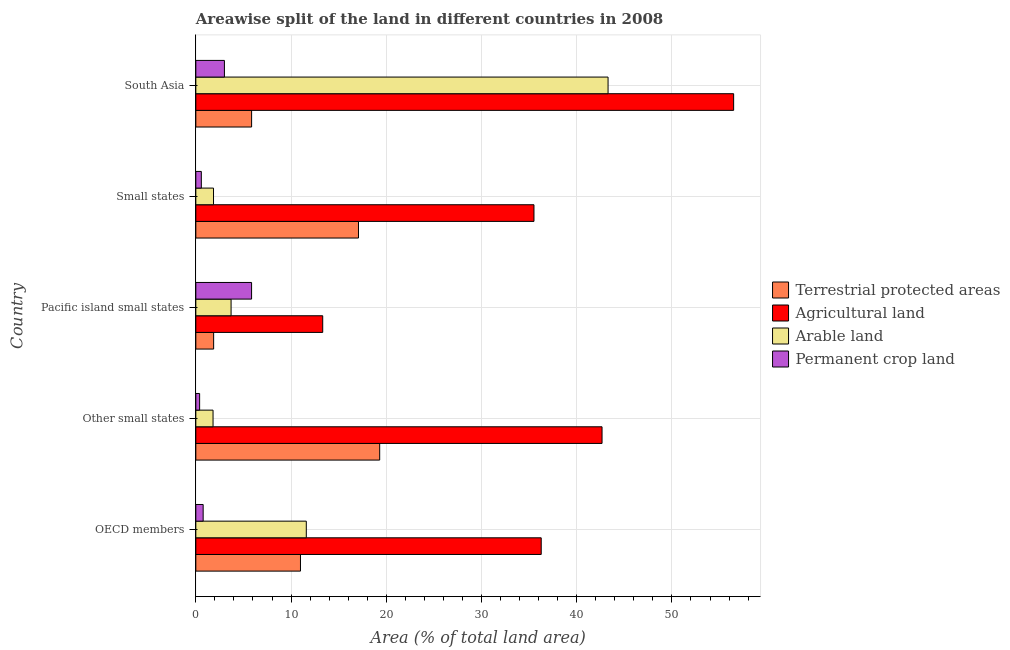Are the number of bars on each tick of the Y-axis equal?
Make the answer very short. Yes. How many bars are there on the 4th tick from the top?
Make the answer very short. 4. What is the label of the 4th group of bars from the top?
Your answer should be very brief. Other small states. In how many cases, is the number of bars for a given country not equal to the number of legend labels?
Your response must be concise. 0. What is the percentage of area under permanent crop land in OECD members?
Offer a terse response. 0.77. Across all countries, what is the maximum percentage of land under terrestrial protection?
Keep it short and to the point. 19.31. Across all countries, what is the minimum percentage of area under permanent crop land?
Your response must be concise. 0.4. In which country was the percentage of area under agricultural land maximum?
Ensure brevity in your answer.  South Asia. In which country was the percentage of area under permanent crop land minimum?
Provide a short and direct response. Other small states. What is the total percentage of area under agricultural land in the graph?
Your response must be concise. 184.26. What is the difference between the percentage of land under terrestrial protection in Other small states and that in South Asia?
Offer a terse response. 13.45. What is the difference between the percentage of land under terrestrial protection in OECD members and the percentage of area under permanent crop land in Other small states?
Your answer should be very brief. 10.59. What is the average percentage of area under agricultural land per country?
Offer a terse response. 36.85. What is the difference between the percentage of area under arable land and percentage of area under agricultural land in Pacific island small states?
Your answer should be compact. -9.62. In how many countries, is the percentage of area under agricultural land greater than 8 %?
Give a very brief answer. 5. What is the ratio of the percentage of area under arable land in OECD members to that in Small states?
Make the answer very short. 6.25. Is the percentage of area under permanent crop land in OECD members less than that in Small states?
Provide a succinct answer. No. What is the difference between the highest and the second highest percentage of land under terrestrial protection?
Keep it short and to the point. 2.23. What is the difference between the highest and the lowest percentage of area under arable land?
Offer a terse response. 41.48. In how many countries, is the percentage of land under terrestrial protection greater than the average percentage of land under terrestrial protection taken over all countries?
Your answer should be compact. 2. Is the sum of the percentage of area under permanent crop land in Pacific island small states and Small states greater than the maximum percentage of area under agricultural land across all countries?
Make the answer very short. No. Is it the case that in every country, the sum of the percentage of land under terrestrial protection and percentage of area under arable land is greater than the sum of percentage of area under agricultural land and percentage of area under permanent crop land?
Your answer should be compact. Yes. What does the 2nd bar from the top in Other small states represents?
Provide a succinct answer. Arable land. What does the 3rd bar from the bottom in Other small states represents?
Your response must be concise. Arable land. Is it the case that in every country, the sum of the percentage of land under terrestrial protection and percentage of area under agricultural land is greater than the percentage of area under arable land?
Make the answer very short. Yes. How many countries are there in the graph?
Provide a short and direct response. 5. What is the difference between two consecutive major ticks on the X-axis?
Provide a short and direct response. 10. Are the values on the major ticks of X-axis written in scientific E-notation?
Provide a short and direct response. No. Does the graph contain grids?
Your answer should be compact. Yes. What is the title of the graph?
Make the answer very short. Areawise split of the land in different countries in 2008. What is the label or title of the X-axis?
Make the answer very short. Area (% of total land area). What is the Area (% of total land area) of Terrestrial protected areas in OECD members?
Offer a terse response. 10.99. What is the Area (% of total land area) in Agricultural land in OECD members?
Give a very brief answer. 36.27. What is the Area (% of total land area) in Arable land in OECD members?
Make the answer very short. 11.6. What is the Area (% of total land area) in Permanent crop land in OECD members?
Your answer should be compact. 0.77. What is the Area (% of total land area) of Terrestrial protected areas in Other small states?
Your answer should be very brief. 19.31. What is the Area (% of total land area) in Agricultural land in Other small states?
Provide a succinct answer. 42.66. What is the Area (% of total land area) of Arable land in Other small states?
Provide a succinct answer. 1.81. What is the Area (% of total land area) in Permanent crop land in Other small states?
Your answer should be compact. 0.4. What is the Area (% of total land area) of Terrestrial protected areas in Pacific island small states?
Offer a terse response. 1.87. What is the Area (% of total land area) in Agricultural land in Pacific island small states?
Make the answer very short. 13.33. What is the Area (% of total land area) in Arable land in Pacific island small states?
Provide a succinct answer. 3.7. What is the Area (% of total land area) of Permanent crop land in Pacific island small states?
Keep it short and to the point. 5.86. What is the Area (% of total land area) of Terrestrial protected areas in Small states?
Provide a short and direct response. 17.08. What is the Area (% of total land area) in Agricultural land in Small states?
Make the answer very short. 35.51. What is the Area (% of total land area) of Arable land in Small states?
Provide a short and direct response. 1.86. What is the Area (% of total land area) of Permanent crop land in Small states?
Your answer should be very brief. 0.58. What is the Area (% of total land area) in Terrestrial protected areas in South Asia?
Provide a succinct answer. 5.86. What is the Area (% of total land area) in Agricultural land in South Asia?
Make the answer very short. 56.48. What is the Area (% of total land area) in Arable land in South Asia?
Ensure brevity in your answer.  43.29. What is the Area (% of total land area) of Permanent crop land in South Asia?
Your answer should be compact. 3. Across all countries, what is the maximum Area (% of total land area) of Terrestrial protected areas?
Ensure brevity in your answer.  19.31. Across all countries, what is the maximum Area (% of total land area) of Agricultural land?
Give a very brief answer. 56.48. Across all countries, what is the maximum Area (% of total land area) in Arable land?
Keep it short and to the point. 43.29. Across all countries, what is the maximum Area (% of total land area) of Permanent crop land?
Keep it short and to the point. 5.86. Across all countries, what is the minimum Area (% of total land area) of Terrestrial protected areas?
Make the answer very short. 1.87. Across all countries, what is the minimum Area (% of total land area) of Agricultural land?
Your answer should be compact. 13.33. Across all countries, what is the minimum Area (% of total land area) in Arable land?
Provide a short and direct response. 1.81. Across all countries, what is the minimum Area (% of total land area) in Permanent crop land?
Keep it short and to the point. 0.4. What is the total Area (% of total land area) in Terrestrial protected areas in the graph?
Your answer should be very brief. 55.11. What is the total Area (% of total land area) of Agricultural land in the graph?
Give a very brief answer. 184.26. What is the total Area (% of total land area) of Arable land in the graph?
Your response must be concise. 62.26. What is the total Area (% of total land area) of Permanent crop land in the graph?
Your answer should be compact. 10.6. What is the difference between the Area (% of total land area) in Terrestrial protected areas in OECD members and that in Other small states?
Make the answer very short. -8.32. What is the difference between the Area (% of total land area) of Agricultural land in OECD members and that in Other small states?
Provide a short and direct response. -6.39. What is the difference between the Area (% of total land area) in Arable land in OECD members and that in Other small states?
Ensure brevity in your answer.  9.79. What is the difference between the Area (% of total land area) of Permanent crop land in OECD members and that in Other small states?
Give a very brief answer. 0.37. What is the difference between the Area (% of total land area) of Terrestrial protected areas in OECD members and that in Pacific island small states?
Offer a terse response. 9.12. What is the difference between the Area (% of total land area) of Agricultural land in OECD members and that in Pacific island small states?
Your answer should be compact. 22.95. What is the difference between the Area (% of total land area) of Arable land in OECD members and that in Pacific island small states?
Offer a terse response. 7.9. What is the difference between the Area (% of total land area) in Permanent crop land in OECD members and that in Pacific island small states?
Offer a terse response. -5.09. What is the difference between the Area (% of total land area) of Terrestrial protected areas in OECD members and that in Small states?
Provide a succinct answer. -6.09. What is the difference between the Area (% of total land area) in Agricultural land in OECD members and that in Small states?
Keep it short and to the point. 0.76. What is the difference between the Area (% of total land area) in Arable land in OECD members and that in Small states?
Offer a very short reply. 9.74. What is the difference between the Area (% of total land area) in Permanent crop land in OECD members and that in Small states?
Your response must be concise. 0.19. What is the difference between the Area (% of total land area) of Terrestrial protected areas in OECD members and that in South Asia?
Ensure brevity in your answer.  5.13. What is the difference between the Area (% of total land area) of Agricultural land in OECD members and that in South Asia?
Provide a short and direct response. -20.21. What is the difference between the Area (% of total land area) of Arable land in OECD members and that in South Asia?
Ensure brevity in your answer.  -31.69. What is the difference between the Area (% of total land area) in Permanent crop land in OECD members and that in South Asia?
Ensure brevity in your answer.  -2.23. What is the difference between the Area (% of total land area) in Terrestrial protected areas in Other small states and that in Pacific island small states?
Your response must be concise. 17.44. What is the difference between the Area (% of total land area) in Agricultural land in Other small states and that in Pacific island small states?
Provide a succinct answer. 29.33. What is the difference between the Area (% of total land area) of Arable land in Other small states and that in Pacific island small states?
Provide a short and direct response. -1.89. What is the difference between the Area (% of total land area) in Permanent crop land in Other small states and that in Pacific island small states?
Make the answer very short. -5.46. What is the difference between the Area (% of total land area) in Terrestrial protected areas in Other small states and that in Small states?
Offer a terse response. 2.23. What is the difference between the Area (% of total land area) of Agricultural land in Other small states and that in Small states?
Make the answer very short. 7.15. What is the difference between the Area (% of total land area) in Arable land in Other small states and that in Small states?
Your answer should be very brief. -0.05. What is the difference between the Area (% of total land area) of Permanent crop land in Other small states and that in Small states?
Keep it short and to the point. -0.18. What is the difference between the Area (% of total land area) of Terrestrial protected areas in Other small states and that in South Asia?
Keep it short and to the point. 13.45. What is the difference between the Area (% of total land area) of Agricultural land in Other small states and that in South Asia?
Your answer should be compact. -13.82. What is the difference between the Area (% of total land area) in Arable land in Other small states and that in South Asia?
Ensure brevity in your answer.  -41.48. What is the difference between the Area (% of total land area) in Permanent crop land in Other small states and that in South Asia?
Offer a terse response. -2.6. What is the difference between the Area (% of total land area) of Terrestrial protected areas in Pacific island small states and that in Small states?
Your answer should be very brief. -15.21. What is the difference between the Area (% of total land area) of Agricultural land in Pacific island small states and that in Small states?
Provide a short and direct response. -22.19. What is the difference between the Area (% of total land area) of Arable land in Pacific island small states and that in Small states?
Make the answer very short. 1.84. What is the difference between the Area (% of total land area) of Permanent crop land in Pacific island small states and that in Small states?
Offer a very short reply. 5.28. What is the difference between the Area (% of total land area) of Terrestrial protected areas in Pacific island small states and that in South Asia?
Give a very brief answer. -3.99. What is the difference between the Area (% of total land area) in Agricultural land in Pacific island small states and that in South Asia?
Your answer should be very brief. -43.16. What is the difference between the Area (% of total land area) of Arable land in Pacific island small states and that in South Asia?
Give a very brief answer. -39.59. What is the difference between the Area (% of total land area) of Permanent crop land in Pacific island small states and that in South Asia?
Your answer should be compact. 2.85. What is the difference between the Area (% of total land area) in Terrestrial protected areas in Small states and that in South Asia?
Offer a very short reply. 11.22. What is the difference between the Area (% of total land area) of Agricultural land in Small states and that in South Asia?
Your response must be concise. -20.97. What is the difference between the Area (% of total land area) of Arable land in Small states and that in South Asia?
Give a very brief answer. -41.44. What is the difference between the Area (% of total land area) of Permanent crop land in Small states and that in South Asia?
Your answer should be very brief. -2.43. What is the difference between the Area (% of total land area) of Terrestrial protected areas in OECD members and the Area (% of total land area) of Agricultural land in Other small states?
Your answer should be compact. -31.67. What is the difference between the Area (% of total land area) of Terrestrial protected areas in OECD members and the Area (% of total land area) of Arable land in Other small states?
Offer a very short reply. 9.18. What is the difference between the Area (% of total land area) in Terrestrial protected areas in OECD members and the Area (% of total land area) in Permanent crop land in Other small states?
Make the answer very short. 10.59. What is the difference between the Area (% of total land area) in Agricultural land in OECD members and the Area (% of total land area) in Arable land in Other small states?
Offer a very short reply. 34.47. What is the difference between the Area (% of total land area) of Agricultural land in OECD members and the Area (% of total land area) of Permanent crop land in Other small states?
Make the answer very short. 35.87. What is the difference between the Area (% of total land area) in Arable land in OECD members and the Area (% of total land area) in Permanent crop land in Other small states?
Ensure brevity in your answer.  11.2. What is the difference between the Area (% of total land area) in Terrestrial protected areas in OECD members and the Area (% of total land area) in Agricultural land in Pacific island small states?
Provide a short and direct response. -2.34. What is the difference between the Area (% of total land area) in Terrestrial protected areas in OECD members and the Area (% of total land area) in Arable land in Pacific island small states?
Offer a very short reply. 7.29. What is the difference between the Area (% of total land area) in Terrestrial protected areas in OECD members and the Area (% of total land area) in Permanent crop land in Pacific island small states?
Give a very brief answer. 5.13. What is the difference between the Area (% of total land area) in Agricultural land in OECD members and the Area (% of total land area) in Arable land in Pacific island small states?
Make the answer very short. 32.57. What is the difference between the Area (% of total land area) in Agricultural land in OECD members and the Area (% of total land area) in Permanent crop land in Pacific island small states?
Your response must be concise. 30.42. What is the difference between the Area (% of total land area) in Arable land in OECD members and the Area (% of total land area) in Permanent crop land in Pacific island small states?
Offer a very short reply. 5.75. What is the difference between the Area (% of total land area) of Terrestrial protected areas in OECD members and the Area (% of total land area) of Agricultural land in Small states?
Make the answer very short. -24.52. What is the difference between the Area (% of total land area) in Terrestrial protected areas in OECD members and the Area (% of total land area) in Arable land in Small states?
Provide a short and direct response. 9.13. What is the difference between the Area (% of total land area) of Terrestrial protected areas in OECD members and the Area (% of total land area) of Permanent crop land in Small states?
Your answer should be very brief. 10.41. What is the difference between the Area (% of total land area) in Agricultural land in OECD members and the Area (% of total land area) in Arable land in Small states?
Your answer should be very brief. 34.42. What is the difference between the Area (% of total land area) in Agricultural land in OECD members and the Area (% of total land area) in Permanent crop land in Small states?
Provide a succinct answer. 35.7. What is the difference between the Area (% of total land area) in Arable land in OECD members and the Area (% of total land area) in Permanent crop land in Small states?
Keep it short and to the point. 11.02. What is the difference between the Area (% of total land area) in Terrestrial protected areas in OECD members and the Area (% of total land area) in Agricultural land in South Asia?
Your response must be concise. -45.49. What is the difference between the Area (% of total land area) of Terrestrial protected areas in OECD members and the Area (% of total land area) of Arable land in South Asia?
Provide a short and direct response. -32.3. What is the difference between the Area (% of total land area) of Terrestrial protected areas in OECD members and the Area (% of total land area) of Permanent crop land in South Asia?
Ensure brevity in your answer.  7.99. What is the difference between the Area (% of total land area) of Agricultural land in OECD members and the Area (% of total land area) of Arable land in South Asia?
Provide a succinct answer. -7.02. What is the difference between the Area (% of total land area) of Agricultural land in OECD members and the Area (% of total land area) of Permanent crop land in South Asia?
Your response must be concise. 33.27. What is the difference between the Area (% of total land area) of Arable land in OECD members and the Area (% of total land area) of Permanent crop land in South Asia?
Your answer should be compact. 8.6. What is the difference between the Area (% of total land area) in Terrestrial protected areas in Other small states and the Area (% of total land area) in Agricultural land in Pacific island small states?
Your answer should be very brief. 5.98. What is the difference between the Area (% of total land area) in Terrestrial protected areas in Other small states and the Area (% of total land area) in Arable land in Pacific island small states?
Make the answer very short. 15.61. What is the difference between the Area (% of total land area) of Terrestrial protected areas in Other small states and the Area (% of total land area) of Permanent crop land in Pacific island small states?
Ensure brevity in your answer.  13.45. What is the difference between the Area (% of total land area) of Agricultural land in Other small states and the Area (% of total land area) of Arable land in Pacific island small states?
Give a very brief answer. 38.96. What is the difference between the Area (% of total land area) in Agricultural land in Other small states and the Area (% of total land area) in Permanent crop land in Pacific island small states?
Your answer should be compact. 36.81. What is the difference between the Area (% of total land area) of Arable land in Other small states and the Area (% of total land area) of Permanent crop land in Pacific island small states?
Ensure brevity in your answer.  -4.05. What is the difference between the Area (% of total land area) of Terrestrial protected areas in Other small states and the Area (% of total land area) of Agricultural land in Small states?
Your answer should be compact. -16.2. What is the difference between the Area (% of total land area) of Terrestrial protected areas in Other small states and the Area (% of total land area) of Arable land in Small states?
Your response must be concise. 17.45. What is the difference between the Area (% of total land area) in Terrestrial protected areas in Other small states and the Area (% of total land area) in Permanent crop land in Small states?
Offer a very short reply. 18.73. What is the difference between the Area (% of total land area) in Agricultural land in Other small states and the Area (% of total land area) in Arable land in Small states?
Provide a short and direct response. 40.8. What is the difference between the Area (% of total land area) of Agricultural land in Other small states and the Area (% of total land area) of Permanent crop land in Small states?
Your answer should be very brief. 42.08. What is the difference between the Area (% of total land area) in Arable land in Other small states and the Area (% of total land area) in Permanent crop land in Small states?
Offer a very short reply. 1.23. What is the difference between the Area (% of total land area) in Terrestrial protected areas in Other small states and the Area (% of total land area) in Agricultural land in South Asia?
Keep it short and to the point. -37.17. What is the difference between the Area (% of total land area) of Terrestrial protected areas in Other small states and the Area (% of total land area) of Arable land in South Asia?
Make the answer very short. -23.98. What is the difference between the Area (% of total land area) in Terrestrial protected areas in Other small states and the Area (% of total land area) in Permanent crop land in South Asia?
Your answer should be compact. 16.3. What is the difference between the Area (% of total land area) of Agricultural land in Other small states and the Area (% of total land area) of Arable land in South Asia?
Make the answer very short. -0.63. What is the difference between the Area (% of total land area) of Agricultural land in Other small states and the Area (% of total land area) of Permanent crop land in South Asia?
Provide a short and direct response. 39.66. What is the difference between the Area (% of total land area) in Arable land in Other small states and the Area (% of total land area) in Permanent crop land in South Asia?
Provide a succinct answer. -1.2. What is the difference between the Area (% of total land area) in Terrestrial protected areas in Pacific island small states and the Area (% of total land area) in Agricultural land in Small states?
Your answer should be compact. -33.64. What is the difference between the Area (% of total land area) of Terrestrial protected areas in Pacific island small states and the Area (% of total land area) of Arable land in Small states?
Make the answer very short. 0.01. What is the difference between the Area (% of total land area) in Terrestrial protected areas in Pacific island small states and the Area (% of total land area) in Permanent crop land in Small states?
Give a very brief answer. 1.29. What is the difference between the Area (% of total land area) of Agricultural land in Pacific island small states and the Area (% of total land area) of Arable land in Small states?
Your response must be concise. 11.47. What is the difference between the Area (% of total land area) in Agricultural land in Pacific island small states and the Area (% of total land area) in Permanent crop land in Small states?
Ensure brevity in your answer.  12.75. What is the difference between the Area (% of total land area) of Arable land in Pacific island small states and the Area (% of total land area) of Permanent crop land in Small states?
Your answer should be compact. 3.12. What is the difference between the Area (% of total land area) in Terrestrial protected areas in Pacific island small states and the Area (% of total land area) in Agricultural land in South Asia?
Offer a very short reply. -54.61. What is the difference between the Area (% of total land area) of Terrestrial protected areas in Pacific island small states and the Area (% of total land area) of Arable land in South Asia?
Offer a terse response. -41.42. What is the difference between the Area (% of total land area) in Terrestrial protected areas in Pacific island small states and the Area (% of total land area) in Permanent crop land in South Asia?
Offer a terse response. -1.13. What is the difference between the Area (% of total land area) in Agricultural land in Pacific island small states and the Area (% of total land area) in Arable land in South Asia?
Give a very brief answer. -29.97. What is the difference between the Area (% of total land area) of Agricultural land in Pacific island small states and the Area (% of total land area) of Permanent crop land in South Asia?
Keep it short and to the point. 10.32. What is the difference between the Area (% of total land area) of Arable land in Pacific island small states and the Area (% of total land area) of Permanent crop land in South Asia?
Provide a succinct answer. 0.7. What is the difference between the Area (% of total land area) in Terrestrial protected areas in Small states and the Area (% of total land area) in Agricultural land in South Asia?
Keep it short and to the point. -39.4. What is the difference between the Area (% of total land area) in Terrestrial protected areas in Small states and the Area (% of total land area) in Arable land in South Asia?
Provide a short and direct response. -26.21. What is the difference between the Area (% of total land area) of Terrestrial protected areas in Small states and the Area (% of total land area) of Permanent crop land in South Asia?
Ensure brevity in your answer.  14.08. What is the difference between the Area (% of total land area) of Agricultural land in Small states and the Area (% of total land area) of Arable land in South Asia?
Provide a succinct answer. -7.78. What is the difference between the Area (% of total land area) of Agricultural land in Small states and the Area (% of total land area) of Permanent crop land in South Asia?
Your answer should be very brief. 32.51. What is the difference between the Area (% of total land area) of Arable land in Small states and the Area (% of total land area) of Permanent crop land in South Asia?
Give a very brief answer. -1.15. What is the average Area (% of total land area) in Terrestrial protected areas per country?
Your answer should be very brief. 11.02. What is the average Area (% of total land area) in Agricultural land per country?
Ensure brevity in your answer.  36.85. What is the average Area (% of total land area) of Arable land per country?
Offer a terse response. 12.45. What is the average Area (% of total land area) of Permanent crop land per country?
Your answer should be compact. 2.12. What is the difference between the Area (% of total land area) in Terrestrial protected areas and Area (% of total land area) in Agricultural land in OECD members?
Your answer should be very brief. -25.28. What is the difference between the Area (% of total land area) of Terrestrial protected areas and Area (% of total land area) of Arable land in OECD members?
Provide a succinct answer. -0.61. What is the difference between the Area (% of total land area) in Terrestrial protected areas and Area (% of total land area) in Permanent crop land in OECD members?
Give a very brief answer. 10.22. What is the difference between the Area (% of total land area) of Agricultural land and Area (% of total land area) of Arable land in OECD members?
Your response must be concise. 24.67. What is the difference between the Area (% of total land area) in Agricultural land and Area (% of total land area) in Permanent crop land in OECD members?
Your answer should be very brief. 35.5. What is the difference between the Area (% of total land area) of Arable land and Area (% of total land area) of Permanent crop land in OECD members?
Provide a succinct answer. 10.83. What is the difference between the Area (% of total land area) in Terrestrial protected areas and Area (% of total land area) in Agricultural land in Other small states?
Provide a succinct answer. -23.35. What is the difference between the Area (% of total land area) in Terrestrial protected areas and Area (% of total land area) in Arable land in Other small states?
Offer a very short reply. 17.5. What is the difference between the Area (% of total land area) in Terrestrial protected areas and Area (% of total land area) in Permanent crop land in Other small states?
Provide a succinct answer. 18.91. What is the difference between the Area (% of total land area) in Agricultural land and Area (% of total land area) in Arable land in Other small states?
Keep it short and to the point. 40.85. What is the difference between the Area (% of total land area) in Agricultural land and Area (% of total land area) in Permanent crop land in Other small states?
Your response must be concise. 42.26. What is the difference between the Area (% of total land area) of Arable land and Area (% of total land area) of Permanent crop land in Other small states?
Give a very brief answer. 1.41. What is the difference between the Area (% of total land area) of Terrestrial protected areas and Area (% of total land area) of Agricultural land in Pacific island small states?
Give a very brief answer. -11.46. What is the difference between the Area (% of total land area) of Terrestrial protected areas and Area (% of total land area) of Arable land in Pacific island small states?
Give a very brief answer. -1.83. What is the difference between the Area (% of total land area) of Terrestrial protected areas and Area (% of total land area) of Permanent crop land in Pacific island small states?
Provide a succinct answer. -3.99. What is the difference between the Area (% of total land area) of Agricultural land and Area (% of total land area) of Arable land in Pacific island small states?
Ensure brevity in your answer.  9.62. What is the difference between the Area (% of total land area) in Agricultural land and Area (% of total land area) in Permanent crop land in Pacific island small states?
Provide a succinct answer. 7.47. What is the difference between the Area (% of total land area) of Arable land and Area (% of total land area) of Permanent crop land in Pacific island small states?
Offer a terse response. -2.15. What is the difference between the Area (% of total land area) in Terrestrial protected areas and Area (% of total land area) in Agricultural land in Small states?
Keep it short and to the point. -18.43. What is the difference between the Area (% of total land area) in Terrestrial protected areas and Area (% of total land area) in Arable land in Small states?
Your response must be concise. 15.22. What is the difference between the Area (% of total land area) in Terrestrial protected areas and Area (% of total land area) in Permanent crop land in Small states?
Provide a succinct answer. 16.5. What is the difference between the Area (% of total land area) in Agricultural land and Area (% of total land area) in Arable land in Small states?
Keep it short and to the point. 33.66. What is the difference between the Area (% of total land area) of Agricultural land and Area (% of total land area) of Permanent crop land in Small states?
Make the answer very short. 34.93. What is the difference between the Area (% of total land area) of Arable land and Area (% of total land area) of Permanent crop land in Small states?
Provide a succinct answer. 1.28. What is the difference between the Area (% of total land area) in Terrestrial protected areas and Area (% of total land area) in Agricultural land in South Asia?
Your response must be concise. -50.62. What is the difference between the Area (% of total land area) of Terrestrial protected areas and Area (% of total land area) of Arable land in South Asia?
Offer a very short reply. -37.44. What is the difference between the Area (% of total land area) of Terrestrial protected areas and Area (% of total land area) of Permanent crop land in South Asia?
Make the answer very short. 2.85. What is the difference between the Area (% of total land area) in Agricultural land and Area (% of total land area) in Arable land in South Asia?
Give a very brief answer. 13.19. What is the difference between the Area (% of total land area) of Agricultural land and Area (% of total land area) of Permanent crop land in South Asia?
Keep it short and to the point. 53.48. What is the difference between the Area (% of total land area) of Arable land and Area (% of total land area) of Permanent crop land in South Asia?
Make the answer very short. 40.29. What is the ratio of the Area (% of total land area) of Terrestrial protected areas in OECD members to that in Other small states?
Provide a succinct answer. 0.57. What is the ratio of the Area (% of total land area) in Agricultural land in OECD members to that in Other small states?
Provide a succinct answer. 0.85. What is the ratio of the Area (% of total land area) in Arable land in OECD members to that in Other small states?
Provide a succinct answer. 6.41. What is the ratio of the Area (% of total land area) of Permanent crop land in OECD members to that in Other small states?
Your answer should be very brief. 1.93. What is the ratio of the Area (% of total land area) of Terrestrial protected areas in OECD members to that in Pacific island small states?
Offer a very short reply. 5.88. What is the ratio of the Area (% of total land area) in Agricultural land in OECD members to that in Pacific island small states?
Give a very brief answer. 2.72. What is the ratio of the Area (% of total land area) in Arable land in OECD members to that in Pacific island small states?
Offer a very short reply. 3.13. What is the ratio of the Area (% of total land area) in Permanent crop land in OECD members to that in Pacific island small states?
Your answer should be compact. 0.13. What is the ratio of the Area (% of total land area) in Terrestrial protected areas in OECD members to that in Small states?
Ensure brevity in your answer.  0.64. What is the ratio of the Area (% of total land area) in Agricultural land in OECD members to that in Small states?
Your answer should be compact. 1.02. What is the ratio of the Area (% of total land area) in Arable land in OECD members to that in Small states?
Provide a short and direct response. 6.25. What is the ratio of the Area (% of total land area) in Permanent crop land in OECD members to that in Small states?
Provide a succinct answer. 1.33. What is the ratio of the Area (% of total land area) of Terrestrial protected areas in OECD members to that in South Asia?
Provide a succinct answer. 1.88. What is the ratio of the Area (% of total land area) of Agricultural land in OECD members to that in South Asia?
Make the answer very short. 0.64. What is the ratio of the Area (% of total land area) in Arable land in OECD members to that in South Asia?
Keep it short and to the point. 0.27. What is the ratio of the Area (% of total land area) in Permanent crop land in OECD members to that in South Asia?
Offer a terse response. 0.26. What is the ratio of the Area (% of total land area) of Terrestrial protected areas in Other small states to that in Pacific island small states?
Your answer should be very brief. 10.33. What is the ratio of the Area (% of total land area) of Agricultural land in Other small states to that in Pacific island small states?
Offer a very short reply. 3.2. What is the ratio of the Area (% of total land area) in Arable land in Other small states to that in Pacific island small states?
Keep it short and to the point. 0.49. What is the ratio of the Area (% of total land area) in Permanent crop land in Other small states to that in Pacific island small states?
Your response must be concise. 0.07. What is the ratio of the Area (% of total land area) of Terrestrial protected areas in Other small states to that in Small states?
Ensure brevity in your answer.  1.13. What is the ratio of the Area (% of total land area) in Agricultural land in Other small states to that in Small states?
Provide a succinct answer. 1.2. What is the ratio of the Area (% of total land area) in Arable land in Other small states to that in Small states?
Offer a very short reply. 0.97. What is the ratio of the Area (% of total land area) of Permanent crop land in Other small states to that in Small states?
Provide a short and direct response. 0.69. What is the ratio of the Area (% of total land area) in Terrestrial protected areas in Other small states to that in South Asia?
Offer a terse response. 3.3. What is the ratio of the Area (% of total land area) of Agricultural land in Other small states to that in South Asia?
Provide a short and direct response. 0.76. What is the ratio of the Area (% of total land area) in Arable land in Other small states to that in South Asia?
Your answer should be compact. 0.04. What is the ratio of the Area (% of total land area) of Permanent crop land in Other small states to that in South Asia?
Ensure brevity in your answer.  0.13. What is the ratio of the Area (% of total land area) of Terrestrial protected areas in Pacific island small states to that in Small states?
Give a very brief answer. 0.11. What is the ratio of the Area (% of total land area) of Agricultural land in Pacific island small states to that in Small states?
Your response must be concise. 0.38. What is the ratio of the Area (% of total land area) in Arable land in Pacific island small states to that in Small states?
Keep it short and to the point. 1.99. What is the ratio of the Area (% of total land area) in Permanent crop land in Pacific island small states to that in Small states?
Keep it short and to the point. 10.13. What is the ratio of the Area (% of total land area) of Terrestrial protected areas in Pacific island small states to that in South Asia?
Offer a very short reply. 0.32. What is the ratio of the Area (% of total land area) of Agricultural land in Pacific island small states to that in South Asia?
Your answer should be very brief. 0.24. What is the ratio of the Area (% of total land area) in Arable land in Pacific island small states to that in South Asia?
Ensure brevity in your answer.  0.09. What is the ratio of the Area (% of total land area) of Permanent crop land in Pacific island small states to that in South Asia?
Give a very brief answer. 1.95. What is the ratio of the Area (% of total land area) of Terrestrial protected areas in Small states to that in South Asia?
Ensure brevity in your answer.  2.92. What is the ratio of the Area (% of total land area) of Agricultural land in Small states to that in South Asia?
Give a very brief answer. 0.63. What is the ratio of the Area (% of total land area) in Arable land in Small states to that in South Asia?
Your response must be concise. 0.04. What is the ratio of the Area (% of total land area) of Permanent crop land in Small states to that in South Asia?
Make the answer very short. 0.19. What is the difference between the highest and the second highest Area (% of total land area) in Terrestrial protected areas?
Your answer should be very brief. 2.23. What is the difference between the highest and the second highest Area (% of total land area) in Agricultural land?
Give a very brief answer. 13.82. What is the difference between the highest and the second highest Area (% of total land area) of Arable land?
Your response must be concise. 31.69. What is the difference between the highest and the second highest Area (% of total land area) in Permanent crop land?
Ensure brevity in your answer.  2.85. What is the difference between the highest and the lowest Area (% of total land area) in Terrestrial protected areas?
Offer a terse response. 17.44. What is the difference between the highest and the lowest Area (% of total land area) in Agricultural land?
Provide a short and direct response. 43.16. What is the difference between the highest and the lowest Area (% of total land area) of Arable land?
Offer a very short reply. 41.48. What is the difference between the highest and the lowest Area (% of total land area) in Permanent crop land?
Provide a succinct answer. 5.46. 